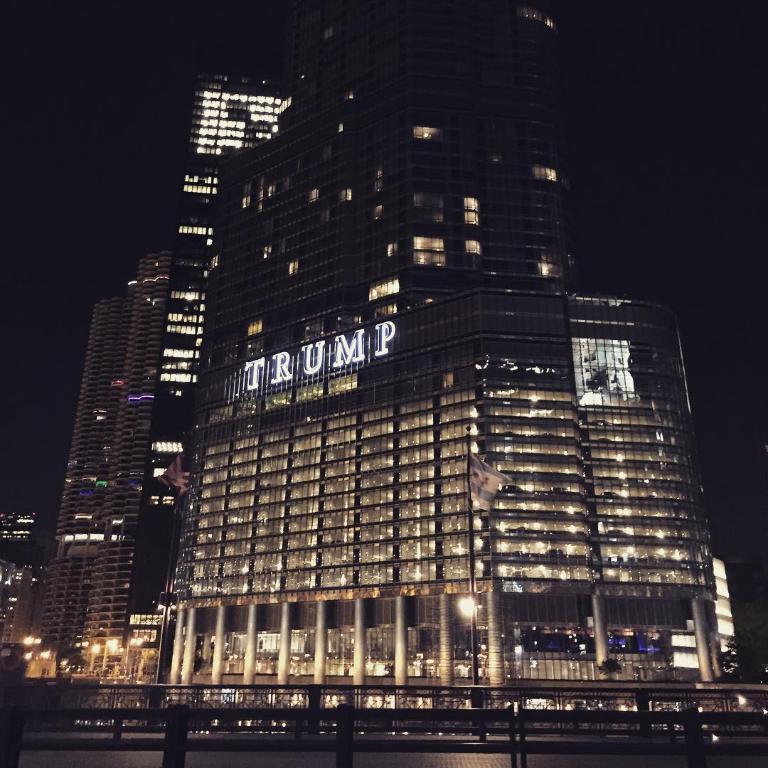Whose tower is this?
Offer a terse response. Trump. 